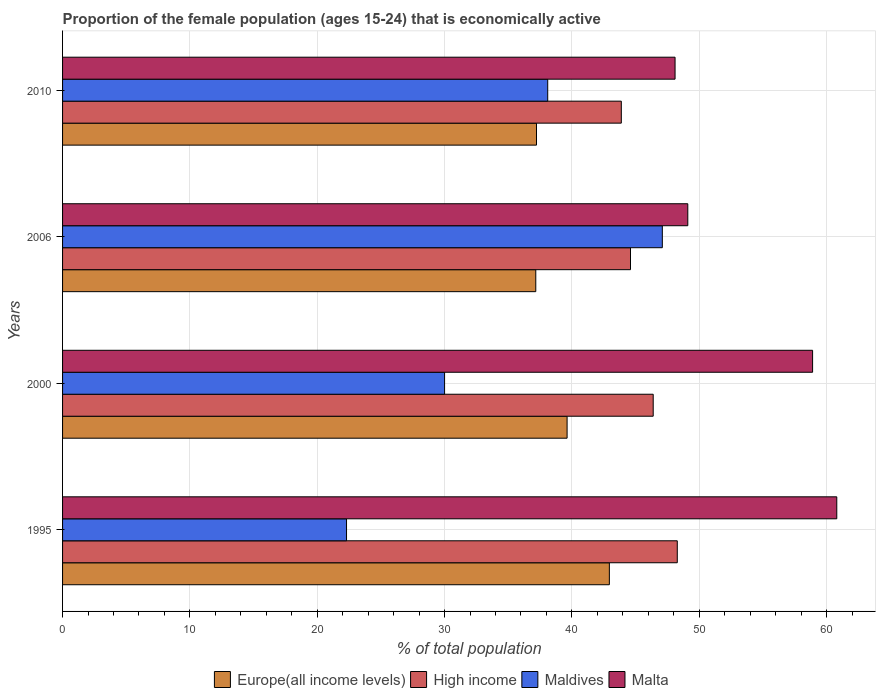How many different coloured bars are there?
Your answer should be compact. 4. Are the number of bars per tick equal to the number of legend labels?
Your response must be concise. Yes. Are the number of bars on each tick of the Y-axis equal?
Keep it short and to the point. Yes. How many bars are there on the 4th tick from the top?
Your answer should be compact. 4. How many bars are there on the 3rd tick from the bottom?
Your answer should be very brief. 4. What is the proportion of the female population that is economically active in Maldives in 1995?
Your answer should be compact. 22.3. Across all years, what is the maximum proportion of the female population that is economically active in Malta?
Make the answer very short. 60.8. Across all years, what is the minimum proportion of the female population that is economically active in High income?
Your response must be concise. 43.88. What is the total proportion of the female population that is economically active in Malta in the graph?
Give a very brief answer. 216.9. What is the difference between the proportion of the female population that is economically active in High income in 2006 and that in 2010?
Keep it short and to the point. 0.72. What is the difference between the proportion of the female population that is economically active in High income in 2006 and the proportion of the female population that is economically active in Maldives in 2000?
Provide a short and direct response. 14.6. What is the average proportion of the female population that is economically active in Maldives per year?
Give a very brief answer. 34.37. In the year 2006, what is the difference between the proportion of the female population that is economically active in High income and proportion of the female population that is economically active in Europe(all income levels)?
Provide a succinct answer. 7.44. In how many years, is the proportion of the female population that is economically active in Europe(all income levels) greater than 38 %?
Offer a very short reply. 2. What is the ratio of the proportion of the female population that is economically active in High income in 2000 to that in 2006?
Make the answer very short. 1.04. Is the proportion of the female population that is economically active in Maldives in 1995 less than that in 2010?
Offer a very short reply. Yes. Is the difference between the proportion of the female population that is economically active in High income in 2000 and 2010 greater than the difference between the proportion of the female population that is economically active in Europe(all income levels) in 2000 and 2010?
Make the answer very short. Yes. What is the difference between the highest and the second highest proportion of the female population that is economically active in Malta?
Give a very brief answer. 1.9. What is the difference between the highest and the lowest proportion of the female population that is economically active in Malta?
Give a very brief answer. 12.7. In how many years, is the proportion of the female population that is economically active in Malta greater than the average proportion of the female population that is economically active in Malta taken over all years?
Offer a very short reply. 2. Is the sum of the proportion of the female population that is economically active in Maldives in 2000 and 2006 greater than the maximum proportion of the female population that is economically active in High income across all years?
Give a very brief answer. Yes. What does the 2nd bar from the top in 2006 represents?
Offer a terse response. Maldives. What does the 1st bar from the bottom in 2010 represents?
Provide a short and direct response. Europe(all income levels). Are the values on the major ticks of X-axis written in scientific E-notation?
Your response must be concise. No. Does the graph contain any zero values?
Your answer should be very brief. No. Where does the legend appear in the graph?
Provide a short and direct response. Bottom center. How many legend labels are there?
Provide a short and direct response. 4. What is the title of the graph?
Offer a terse response. Proportion of the female population (ages 15-24) that is economically active. What is the label or title of the X-axis?
Ensure brevity in your answer.  % of total population. What is the % of total population in Europe(all income levels) in 1995?
Offer a terse response. 42.94. What is the % of total population in High income in 1995?
Provide a short and direct response. 48.27. What is the % of total population of Maldives in 1995?
Give a very brief answer. 22.3. What is the % of total population in Malta in 1995?
Give a very brief answer. 60.8. What is the % of total population of Europe(all income levels) in 2000?
Your answer should be very brief. 39.62. What is the % of total population in High income in 2000?
Your response must be concise. 46.38. What is the % of total population of Malta in 2000?
Your answer should be compact. 58.9. What is the % of total population in Europe(all income levels) in 2006?
Your answer should be compact. 37.16. What is the % of total population in High income in 2006?
Provide a succinct answer. 44.6. What is the % of total population of Maldives in 2006?
Give a very brief answer. 47.1. What is the % of total population in Malta in 2006?
Offer a very short reply. 49.1. What is the % of total population of Europe(all income levels) in 2010?
Your answer should be compact. 37.22. What is the % of total population in High income in 2010?
Provide a short and direct response. 43.88. What is the % of total population in Maldives in 2010?
Your response must be concise. 38.1. What is the % of total population of Malta in 2010?
Provide a succinct answer. 48.1. Across all years, what is the maximum % of total population of Europe(all income levels)?
Ensure brevity in your answer.  42.94. Across all years, what is the maximum % of total population in High income?
Ensure brevity in your answer.  48.27. Across all years, what is the maximum % of total population of Maldives?
Provide a succinct answer. 47.1. Across all years, what is the maximum % of total population in Malta?
Your response must be concise. 60.8. Across all years, what is the minimum % of total population of Europe(all income levels)?
Give a very brief answer. 37.16. Across all years, what is the minimum % of total population in High income?
Ensure brevity in your answer.  43.88. Across all years, what is the minimum % of total population of Maldives?
Keep it short and to the point. 22.3. Across all years, what is the minimum % of total population of Malta?
Your answer should be very brief. 48.1. What is the total % of total population of Europe(all income levels) in the graph?
Keep it short and to the point. 156.94. What is the total % of total population in High income in the graph?
Provide a succinct answer. 183.14. What is the total % of total population of Maldives in the graph?
Keep it short and to the point. 137.5. What is the total % of total population of Malta in the graph?
Provide a short and direct response. 216.9. What is the difference between the % of total population of Europe(all income levels) in 1995 and that in 2000?
Your response must be concise. 3.32. What is the difference between the % of total population in High income in 1995 and that in 2000?
Provide a succinct answer. 1.89. What is the difference between the % of total population of Maldives in 1995 and that in 2000?
Provide a succinct answer. -7.7. What is the difference between the % of total population in Malta in 1995 and that in 2000?
Give a very brief answer. 1.9. What is the difference between the % of total population of Europe(all income levels) in 1995 and that in 2006?
Offer a very short reply. 5.78. What is the difference between the % of total population in High income in 1995 and that in 2006?
Offer a terse response. 3.67. What is the difference between the % of total population of Maldives in 1995 and that in 2006?
Keep it short and to the point. -24.8. What is the difference between the % of total population of Europe(all income levels) in 1995 and that in 2010?
Your answer should be very brief. 5.72. What is the difference between the % of total population of High income in 1995 and that in 2010?
Keep it short and to the point. 4.4. What is the difference between the % of total population of Maldives in 1995 and that in 2010?
Ensure brevity in your answer.  -15.8. What is the difference between the % of total population in Malta in 1995 and that in 2010?
Your response must be concise. 12.7. What is the difference between the % of total population of Europe(all income levels) in 2000 and that in 2006?
Give a very brief answer. 2.46. What is the difference between the % of total population in High income in 2000 and that in 2006?
Offer a very short reply. 1.78. What is the difference between the % of total population in Maldives in 2000 and that in 2006?
Provide a short and direct response. -17.1. What is the difference between the % of total population in Malta in 2000 and that in 2006?
Offer a very short reply. 9.8. What is the difference between the % of total population of Europe(all income levels) in 2000 and that in 2010?
Your response must be concise. 2.4. What is the difference between the % of total population in High income in 2000 and that in 2010?
Provide a short and direct response. 2.5. What is the difference between the % of total population in Maldives in 2000 and that in 2010?
Ensure brevity in your answer.  -8.1. What is the difference between the % of total population in Europe(all income levels) in 2006 and that in 2010?
Keep it short and to the point. -0.06. What is the difference between the % of total population of High income in 2006 and that in 2010?
Give a very brief answer. 0.72. What is the difference between the % of total population of Maldives in 2006 and that in 2010?
Offer a terse response. 9. What is the difference between the % of total population of Europe(all income levels) in 1995 and the % of total population of High income in 2000?
Make the answer very short. -3.44. What is the difference between the % of total population in Europe(all income levels) in 1995 and the % of total population in Maldives in 2000?
Provide a succinct answer. 12.94. What is the difference between the % of total population of Europe(all income levels) in 1995 and the % of total population of Malta in 2000?
Offer a terse response. -15.96. What is the difference between the % of total population of High income in 1995 and the % of total population of Maldives in 2000?
Your response must be concise. 18.27. What is the difference between the % of total population in High income in 1995 and the % of total population in Malta in 2000?
Make the answer very short. -10.63. What is the difference between the % of total population of Maldives in 1995 and the % of total population of Malta in 2000?
Your answer should be very brief. -36.6. What is the difference between the % of total population of Europe(all income levels) in 1995 and the % of total population of High income in 2006?
Offer a terse response. -1.66. What is the difference between the % of total population in Europe(all income levels) in 1995 and the % of total population in Maldives in 2006?
Keep it short and to the point. -4.16. What is the difference between the % of total population of Europe(all income levels) in 1995 and the % of total population of Malta in 2006?
Provide a succinct answer. -6.16. What is the difference between the % of total population of High income in 1995 and the % of total population of Maldives in 2006?
Your answer should be compact. 1.17. What is the difference between the % of total population of High income in 1995 and the % of total population of Malta in 2006?
Your answer should be very brief. -0.83. What is the difference between the % of total population of Maldives in 1995 and the % of total population of Malta in 2006?
Ensure brevity in your answer.  -26.8. What is the difference between the % of total population of Europe(all income levels) in 1995 and the % of total population of High income in 2010?
Your answer should be very brief. -0.94. What is the difference between the % of total population of Europe(all income levels) in 1995 and the % of total population of Maldives in 2010?
Keep it short and to the point. 4.84. What is the difference between the % of total population of Europe(all income levels) in 1995 and the % of total population of Malta in 2010?
Ensure brevity in your answer.  -5.16. What is the difference between the % of total population in High income in 1995 and the % of total population in Maldives in 2010?
Your response must be concise. 10.17. What is the difference between the % of total population of High income in 1995 and the % of total population of Malta in 2010?
Offer a terse response. 0.17. What is the difference between the % of total population of Maldives in 1995 and the % of total population of Malta in 2010?
Your answer should be very brief. -25.8. What is the difference between the % of total population in Europe(all income levels) in 2000 and the % of total population in High income in 2006?
Your answer should be very brief. -4.98. What is the difference between the % of total population in Europe(all income levels) in 2000 and the % of total population in Maldives in 2006?
Your answer should be compact. -7.48. What is the difference between the % of total population of Europe(all income levels) in 2000 and the % of total population of Malta in 2006?
Your answer should be compact. -9.48. What is the difference between the % of total population of High income in 2000 and the % of total population of Maldives in 2006?
Offer a very short reply. -0.72. What is the difference between the % of total population in High income in 2000 and the % of total population in Malta in 2006?
Offer a terse response. -2.72. What is the difference between the % of total population of Maldives in 2000 and the % of total population of Malta in 2006?
Keep it short and to the point. -19.1. What is the difference between the % of total population of Europe(all income levels) in 2000 and the % of total population of High income in 2010?
Make the answer very short. -4.26. What is the difference between the % of total population in Europe(all income levels) in 2000 and the % of total population in Maldives in 2010?
Your answer should be very brief. 1.52. What is the difference between the % of total population of Europe(all income levels) in 2000 and the % of total population of Malta in 2010?
Provide a succinct answer. -8.48. What is the difference between the % of total population of High income in 2000 and the % of total population of Maldives in 2010?
Make the answer very short. 8.28. What is the difference between the % of total population of High income in 2000 and the % of total population of Malta in 2010?
Your answer should be compact. -1.72. What is the difference between the % of total population in Maldives in 2000 and the % of total population in Malta in 2010?
Keep it short and to the point. -18.1. What is the difference between the % of total population of Europe(all income levels) in 2006 and the % of total population of High income in 2010?
Give a very brief answer. -6.72. What is the difference between the % of total population in Europe(all income levels) in 2006 and the % of total population in Maldives in 2010?
Provide a short and direct response. -0.94. What is the difference between the % of total population of Europe(all income levels) in 2006 and the % of total population of Malta in 2010?
Your response must be concise. -10.94. What is the difference between the % of total population in High income in 2006 and the % of total population in Maldives in 2010?
Ensure brevity in your answer.  6.5. What is the difference between the % of total population in High income in 2006 and the % of total population in Malta in 2010?
Provide a succinct answer. -3.5. What is the difference between the % of total population of Maldives in 2006 and the % of total population of Malta in 2010?
Make the answer very short. -1. What is the average % of total population in Europe(all income levels) per year?
Provide a succinct answer. 39.24. What is the average % of total population in High income per year?
Ensure brevity in your answer.  45.78. What is the average % of total population of Maldives per year?
Offer a very short reply. 34.38. What is the average % of total population in Malta per year?
Ensure brevity in your answer.  54.23. In the year 1995, what is the difference between the % of total population of Europe(all income levels) and % of total population of High income?
Provide a succinct answer. -5.33. In the year 1995, what is the difference between the % of total population of Europe(all income levels) and % of total population of Maldives?
Ensure brevity in your answer.  20.64. In the year 1995, what is the difference between the % of total population of Europe(all income levels) and % of total population of Malta?
Provide a succinct answer. -17.86. In the year 1995, what is the difference between the % of total population of High income and % of total population of Maldives?
Provide a short and direct response. 25.97. In the year 1995, what is the difference between the % of total population of High income and % of total population of Malta?
Your answer should be very brief. -12.53. In the year 1995, what is the difference between the % of total population of Maldives and % of total population of Malta?
Provide a succinct answer. -38.5. In the year 2000, what is the difference between the % of total population of Europe(all income levels) and % of total population of High income?
Provide a succinct answer. -6.76. In the year 2000, what is the difference between the % of total population in Europe(all income levels) and % of total population in Maldives?
Provide a short and direct response. 9.62. In the year 2000, what is the difference between the % of total population in Europe(all income levels) and % of total population in Malta?
Provide a short and direct response. -19.28. In the year 2000, what is the difference between the % of total population in High income and % of total population in Maldives?
Ensure brevity in your answer.  16.38. In the year 2000, what is the difference between the % of total population in High income and % of total population in Malta?
Your response must be concise. -12.52. In the year 2000, what is the difference between the % of total population of Maldives and % of total population of Malta?
Offer a very short reply. -28.9. In the year 2006, what is the difference between the % of total population in Europe(all income levels) and % of total population in High income?
Offer a very short reply. -7.44. In the year 2006, what is the difference between the % of total population in Europe(all income levels) and % of total population in Maldives?
Your answer should be compact. -9.94. In the year 2006, what is the difference between the % of total population in Europe(all income levels) and % of total population in Malta?
Provide a short and direct response. -11.94. In the year 2006, what is the difference between the % of total population in High income and % of total population in Maldives?
Ensure brevity in your answer.  -2.5. In the year 2006, what is the difference between the % of total population of High income and % of total population of Malta?
Offer a terse response. -4.5. In the year 2010, what is the difference between the % of total population of Europe(all income levels) and % of total population of High income?
Ensure brevity in your answer.  -6.66. In the year 2010, what is the difference between the % of total population of Europe(all income levels) and % of total population of Maldives?
Give a very brief answer. -0.88. In the year 2010, what is the difference between the % of total population in Europe(all income levels) and % of total population in Malta?
Offer a very short reply. -10.88. In the year 2010, what is the difference between the % of total population in High income and % of total population in Maldives?
Give a very brief answer. 5.78. In the year 2010, what is the difference between the % of total population in High income and % of total population in Malta?
Provide a succinct answer. -4.22. What is the ratio of the % of total population of Europe(all income levels) in 1995 to that in 2000?
Keep it short and to the point. 1.08. What is the ratio of the % of total population in High income in 1995 to that in 2000?
Make the answer very short. 1.04. What is the ratio of the % of total population in Maldives in 1995 to that in 2000?
Ensure brevity in your answer.  0.74. What is the ratio of the % of total population in Malta in 1995 to that in 2000?
Make the answer very short. 1.03. What is the ratio of the % of total population in Europe(all income levels) in 1995 to that in 2006?
Offer a terse response. 1.16. What is the ratio of the % of total population in High income in 1995 to that in 2006?
Your answer should be compact. 1.08. What is the ratio of the % of total population in Maldives in 1995 to that in 2006?
Offer a terse response. 0.47. What is the ratio of the % of total population in Malta in 1995 to that in 2006?
Keep it short and to the point. 1.24. What is the ratio of the % of total population in Europe(all income levels) in 1995 to that in 2010?
Offer a terse response. 1.15. What is the ratio of the % of total population of High income in 1995 to that in 2010?
Offer a very short reply. 1.1. What is the ratio of the % of total population in Maldives in 1995 to that in 2010?
Offer a very short reply. 0.59. What is the ratio of the % of total population in Malta in 1995 to that in 2010?
Keep it short and to the point. 1.26. What is the ratio of the % of total population of Europe(all income levels) in 2000 to that in 2006?
Offer a terse response. 1.07. What is the ratio of the % of total population in High income in 2000 to that in 2006?
Provide a succinct answer. 1.04. What is the ratio of the % of total population in Maldives in 2000 to that in 2006?
Your answer should be compact. 0.64. What is the ratio of the % of total population in Malta in 2000 to that in 2006?
Your answer should be compact. 1.2. What is the ratio of the % of total population of Europe(all income levels) in 2000 to that in 2010?
Your answer should be very brief. 1.06. What is the ratio of the % of total population in High income in 2000 to that in 2010?
Ensure brevity in your answer.  1.06. What is the ratio of the % of total population in Maldives in 2000 to that in 2010?
Keep it short and to the point. 0.79. What is the ratio of the % of total population in Malta in 2000 to that in 2010?
Your response must be concise. 1.22. What is the ratio of the % of total population in Europe(all income levels) in 2006 to that in 2010?
Ensure brevity in your answer.  1. What is the ratio of the % of total population in High income in 2006 to that in 2010?
Provide a succinct answer. 1.02. What is the ratio of the % of total population in Maldives in 2006 to that in 2010?
Keep it short and to the point. 1.24. What is the ratio of the % of total population in Malta in 2006 to that in 2010?
Keep it short and to the point. 1.02. What is the difference between the highest and the second highest % of total population in Europe(all income levels)?
Offer a terse response. 3.32. What is the difference between the highest and the second highest % of total population in High income?
Your response must be concise. 1.89. What is the difference between the highest and the lowest % of total population in Europe(all income levels)?
Give a very brief answer. 5.78. What is the difference between the highest and the lowest % of total population in High income?
Make the answer very short. 4.4. What is the difference between the highest and the lowest % of total population in Maldives?
Provide a short and direct response. 24.8. What is the difference between the highest and the lowest % of total population in Malta?
Give a very brief answer. 12.7. 